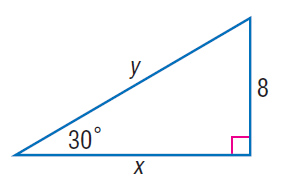Question: Find y.
Choices:
A. 8
B. 8 \sqrt { 3 }
C. 16
D. 16 \sqrt { 3 }
Answer with the letter. Answer: C Question: Find x.
Choices:
A. 8
B. 8 \sqrt { 3 }
C. 16
D. 16 \sqrt { 3 }
Answer with the letter. Answer: B 